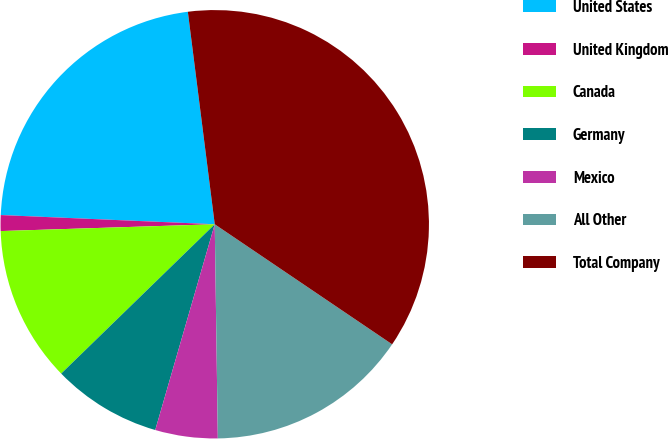Convert chart. <chart><loc_0><loc_0><loc_500><loc_500><pie_chart><fcel>United States<fcel>United Kingdom<fcel>Canada<fcel>Germany<fcel>Mexico<fcel>All Other<fcel>Total Company<nl><fcel>22.31%<fcel>1.19%<fcel>11.77%<fcel>8.24%<fcel>4.71%<fcel>15.3%<fcel>36.47%<nl></chart> 